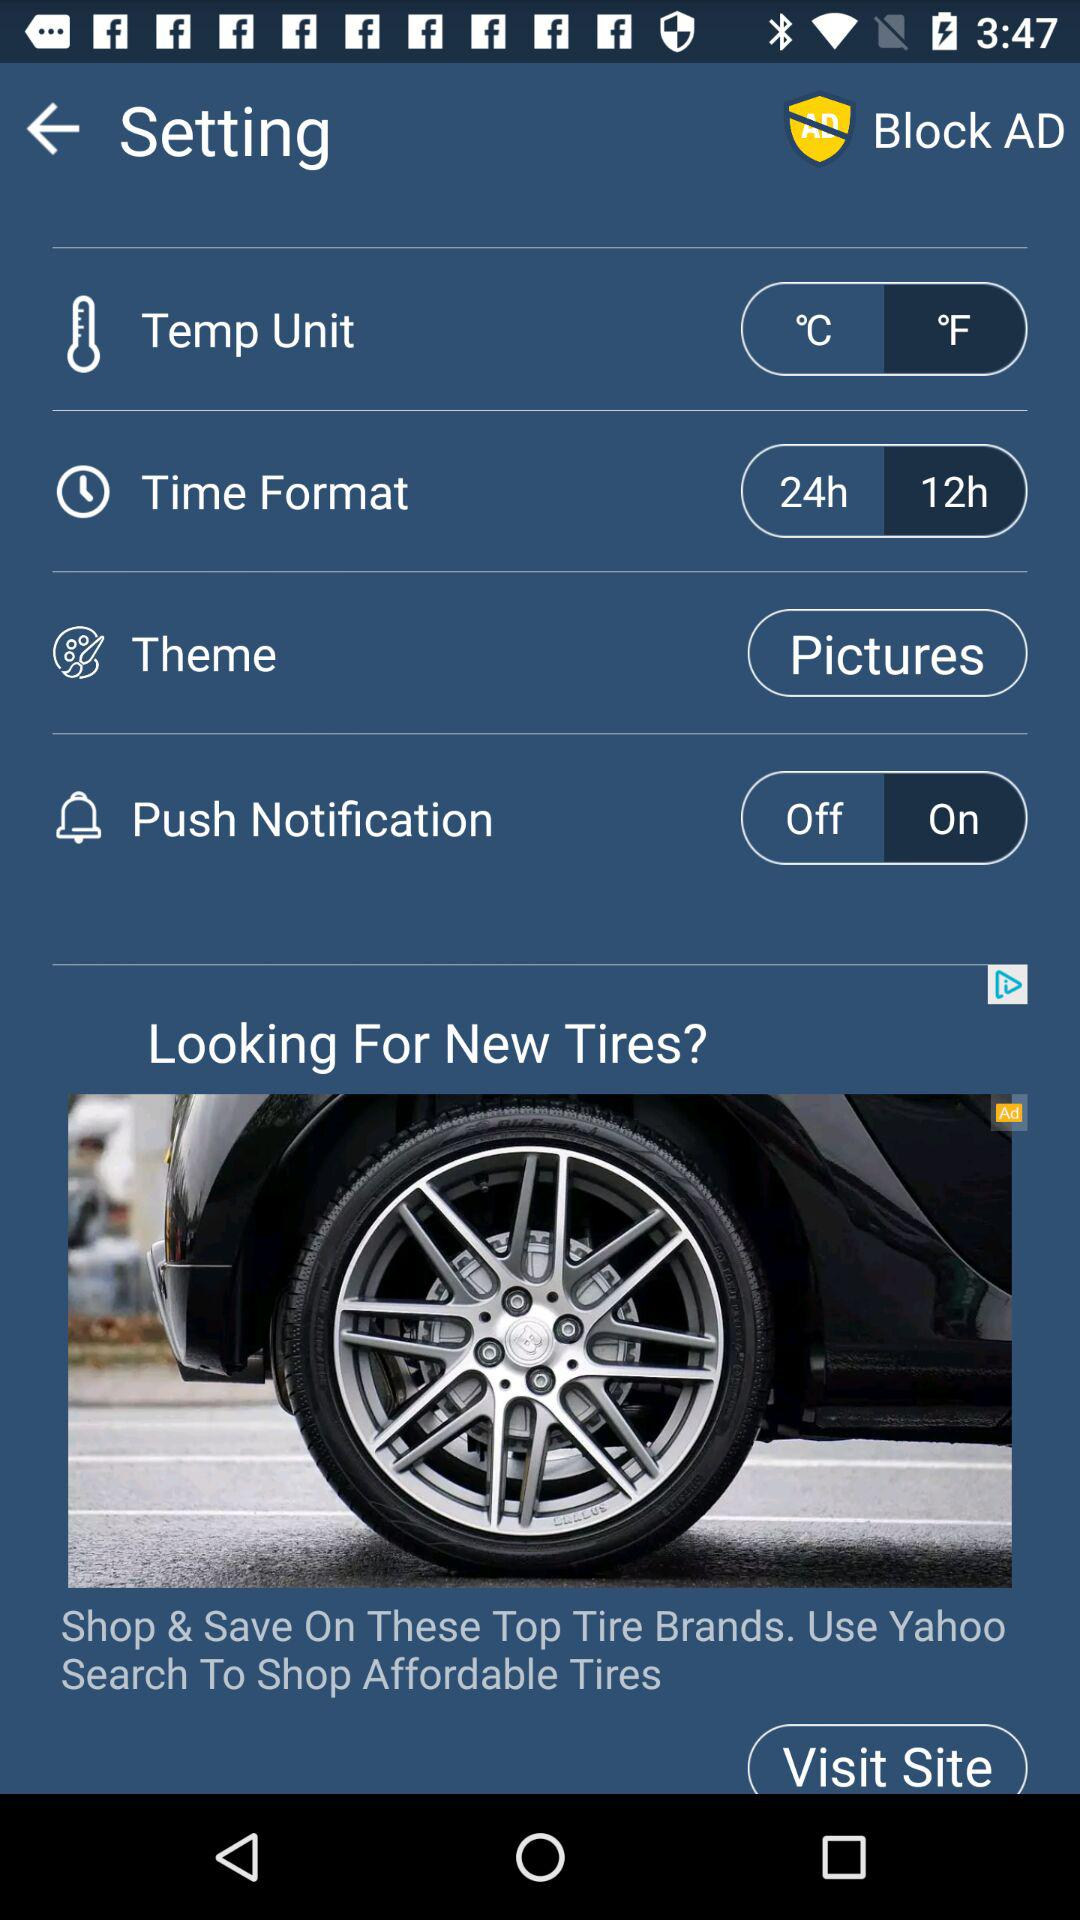What is the temperature unit? The temperature unit is °F. 